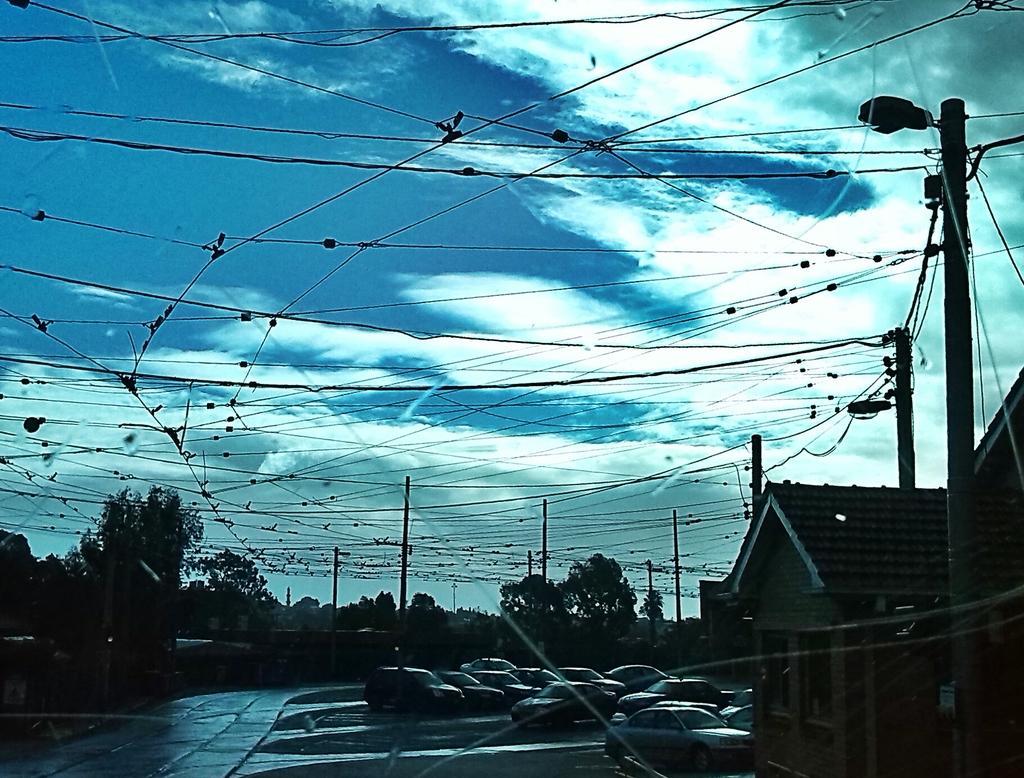How would you summarize this image in a sentence or two? This image is clicked on the road. there are many cars parked on the road. To the right there are houses. Behind the cars there are trees and electric poles. At the top there is the sky. 